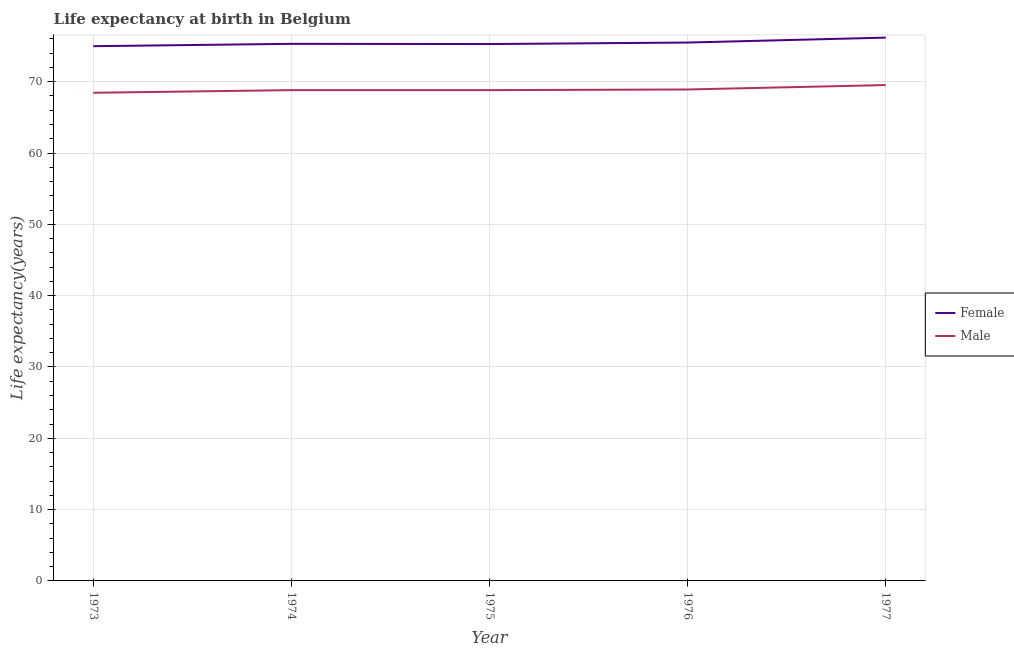How many different coloured lines are there?
Provide a succinct answer. 2. Is the number of lines equal to the number of legend labels?
Your answer should be very brief. Yes. What is the life expectancy(female) in 1973?
Your response must be concise. 74.98. Across all years, what is the maximum life expectancy(female)?
Keep it short and to the point. 76.18. Across all years, what is the minimum life expectancy(male)?
Give a very brief answer. 68.45. What is the total life expectancy(female) in the graph?
Offer a terse response. 377.24. What is the difference between the life expectancy(female) in 1973 and that in 1977?
Your response must be concise. -1.2. What is the difference between the life expectancy(female) in 1974 and the life expectancy(male) in 1977?
Your answer should be compact. 5.78. What is the average life expectancy(female) per year?
Your response must be concise. 75.45. In the year 1974, what is the difference between the life expectancy(female) and life expectancy(male)?
Provide a short and direct response. 6.49. What is the ratio of the life expectancy(female) in 1975 to that in 1977?
Offer a very short reply. 0.99. Is the life expectancy(male) in 1974 less than that in 1977?
Your response must be concise. Yes. What is the difference between the highest and the second highest life expectancy(male)?
Provide a short and direct response. 0.62. What is the difference between the highest and the lowest life expectancy(male)?
Offer a very short reply. 1.08. How many lines are there?
Your response must be concise. 2. How many years are there in the graph?
Your answer should be compact. 5. Are the values on the major ticks of Y-axis written in scientific E-notation?
Offer a very short reply. No. How many legend labels are there?
Offer a very short reply. 2. What is the title of the graph?
Offer a terse response. Life expectancy at birth in Belgium. Does "Quality of trade" appear as one of the legend labels in the graph?
Keep it short and to the point. No. What is the label or title of the Y-axis?
Give a very brief answer. Life expectancy(years). What is the Life expectancy(years) in Female in 1973?
Your response must be concise. 74.98. What is the Life expectancy(years) in Male in 1973?
Provide a succinct answer. 68.45. What is the Life expectancy(years) in Female in 1974?
Give a very brief answer. 75.31. What is the Life expectancy(years) in Male in 1974?
Offer a very short reply. 68.82. What is the Life expectancy(years) of Female in 1975?
Your answer should be very brief. 75.28. What is the Life expectancy(years) of Male in 1975?
Your response must be concise. 68.82. What is the Life expectancy(years) in Female in 1976?
Offer a terse response. 75.49. What is the Life expectancy(years) in Male in 1976?
Your answer should be very brief. 68.91. What is the Life expectancy(years) of Female in 1977?
Make the answer very short. 76.18. What is the Life expectancy(years) in Male in 1977?
Provide a short and direct response. 69.53. Across all years, what is the maximum Life expectancy(years) of Female?
Offer a terse response. 76.18. Across all years, what is the maximum Life expectancy(years) in Male?
Offer a very short reply. 69.53. Across all years, what is the minimum Life expectancy(years) in Female?
Provide a short and direct response. 74.98. Across all years, what is the minimum Life expectancy(years) of Male?
Make the answer very short. 68.45. What is the total Life expectancy(years) in Female in the graph?
Your response must be concise. 377.24. What is the total Life expectancy(years) in Male in the graph?
Your answer should be very brief. 344.53. What is the difference between the Life expectancy(years) in Female in 1973 and that in 1974?
Your answer should be compact. -0.33. What is the difference between the Life expectancy(years) of Male in 1973 and that in 1974?
Your response must be concise. -0.37. What is the difference between the Life expectancy(years) of Female in 1973 and that in 1975?
Provide a short and direct response. -0.3. What is the difference between the Life expectancy(years) of Male in 1973 and that in 1975?
Provide a succinct answer. -0.37. What is the difference between the Life expectancy(years) in Female in 1973 and that in 1976?
Give a very brief answer. -0.51. What is the difference between the Life expectancy(years) in Male in 1973 and that in 1976?
Provide a short and direct response. -0.46. What is the difference between the Life expectancy(years) of Female in 1973 and that in 1977?
Provide a succinct answer. -1.2. What is the difference between the Life expectancy(years) in Male in 1973 and that in 1977?
Your answer should be very brief. -1.08. What is the difference between the Life expectancy(years) of Female in 1974 and that in 1975?
Your answer should be very brief. 0.03. What is the difference between the Life expectancy(years) in Female in 1974 and that in 1976?
Offer a very short reply. -0.18. What is the difference between the Life expectancy(years) of Male in 1974 and that in 1976?
Keep it short and to the point. -0.09. What is the difference between the Life expectancy(years) in Female in 1974 and that in 1977?
Make the answer very short. -0.87. What is the difference between the Life expectancy(years) of Male in 1974 and that in 1977?
Offer a terse response. -0.71. What is the difference between the Life expectancy(years) in Female in 1975 and that in 1976?
Give a very brief answer. -0.21. What is the difference between the Life expectancy(years) in Male in 1975 and that in 1976?
Ensure brevity in your answer.  -0.09. What is the difference between the Life expectancy(years) in Male in 1975 and that in 1977?
Offer a terse response. -0.71. What is the difference between the Life expectancy(years) of Female in 1976 and that in 1977?
Provide a short and direct response. -0.69. What is the difference between the Life expectancy(years) of Male in 1976 and that in 1977?
Your response must be concise. -0.62. What is the difference between the Life expectancy(years) of Female in 1973 and the Life expectancy(years) of Male in 1974?
Offer a very short reply. 6.16. What is the difference between the Life expectancy(years) of Female in 1973 and the Life expectancy(years) of Male in 1975?
Offer a very short reply. 6.16. What is the difference between the Life expectancy(years) in Female in 1973 and the Life expectancy(years) in Male in 1976?
Keep it short and to the point. 6.07. What is the difference between the Life expectancy(years) in Female in 1973 and the Life expectancy(years) in Male in 1977?
Your response must be concise. 5.45. What is the difference between the Life expectancy(years) in Female in 1974 and the Life expectancy(years) in Male in 1975?
Provide a succinct answer. 6.49. What is the difference between the Life expectancy(years) in Female in 1974 and the Life expectancy(years) in Male in 1977?
Provide a short and direct response. 5.78. What is the difference between the Life expectancy(years) of Female in 1975 and the Life expectancy(years) of Male in 1976?
Your response must be concise. 6.37. What is the difference between the Life expectancy(years) of Female in 1975 and the Life expectancy(years) of Male in 1977?
Provide a short and direct response. 5.75. What is the difference between the Life expectancy(years) in Female in 1976 and the Life expectancy(years) in Male in 1977?
Your answer should be compact. 5.96. What is the average Life expectancy(years) in Female per year?
Your answer should be compact. 75.45. What is the average Life expectancy(years) in Male per year?
Provide a succinct answer. 68.91. In the year 1973, what is the difference between the Life expectancy(years) in Female and Life expectancy(years) in Male?
Offer a terse response. 6.53. In the year 1974, what is the difference between the Life expectancy(years) in Female and Life expectancy(years) in Male?
Your answer should be compact. 6.49. In the year 1975, what is the difference between the Life expectancy(years) of Female and Life expectancy(years) of Male?
Offer a very short reply. 6.46. In the year 1976, what is the difference between the Life expectancy(years) in Female and Life expectancy(years) in Male?
Give a very brief answer. 6.58. In the year 1977, what is the difference between the Life expectancy(years) in Female and Life expectancy(years) in Male?
Make the answer very short. 6.65. What is the ratio of the Life expectancy(years) in Male in 1973 to that in 1975?
Your answer should be very brief. 0.99. What is the ratio of the Life expectancy(years) of Female in 1973 to that in 1976?
Your answer should be very brief. 0.99. What is the ratio of the Life expectancy(years) in Male in 1973 to that in 1976?
Your answer should be compact. 0.99. What is the ratio of the Life expectancy(years) in Female in 1973 to that in 1977?
Keep it short and to the point. 0.98. What is the ratio of the Life expectancy(years) in Male in 1973 to that in 1977?
Ensure brevity in your answer.  0.98. What is the ratio of the Life expectancy(years) in Female in 1974 to that in 1975?
Give a very brief answer. 1. What is the ratio of the Life expectancy(years) of Female in 1974 to that in 1977?
Offer a terse response. 0.99. What is the ratio of the Life expectancy(years) in Female in 1975 to that in 1976?
Provide a succinct answer. 1. What is the ratio of the Life expectancy(years) of Female in 1976 to that in 1977?
Your answer should be very brief. 0.99. What is the difference between the highest and the second highest Life expectancy(years) of Female?
Keep it short and to the point. 0.69. What is the difference between the highest and the second highest Life expectancy(years) in Male?
Provide a short and direct response. 0.62. 